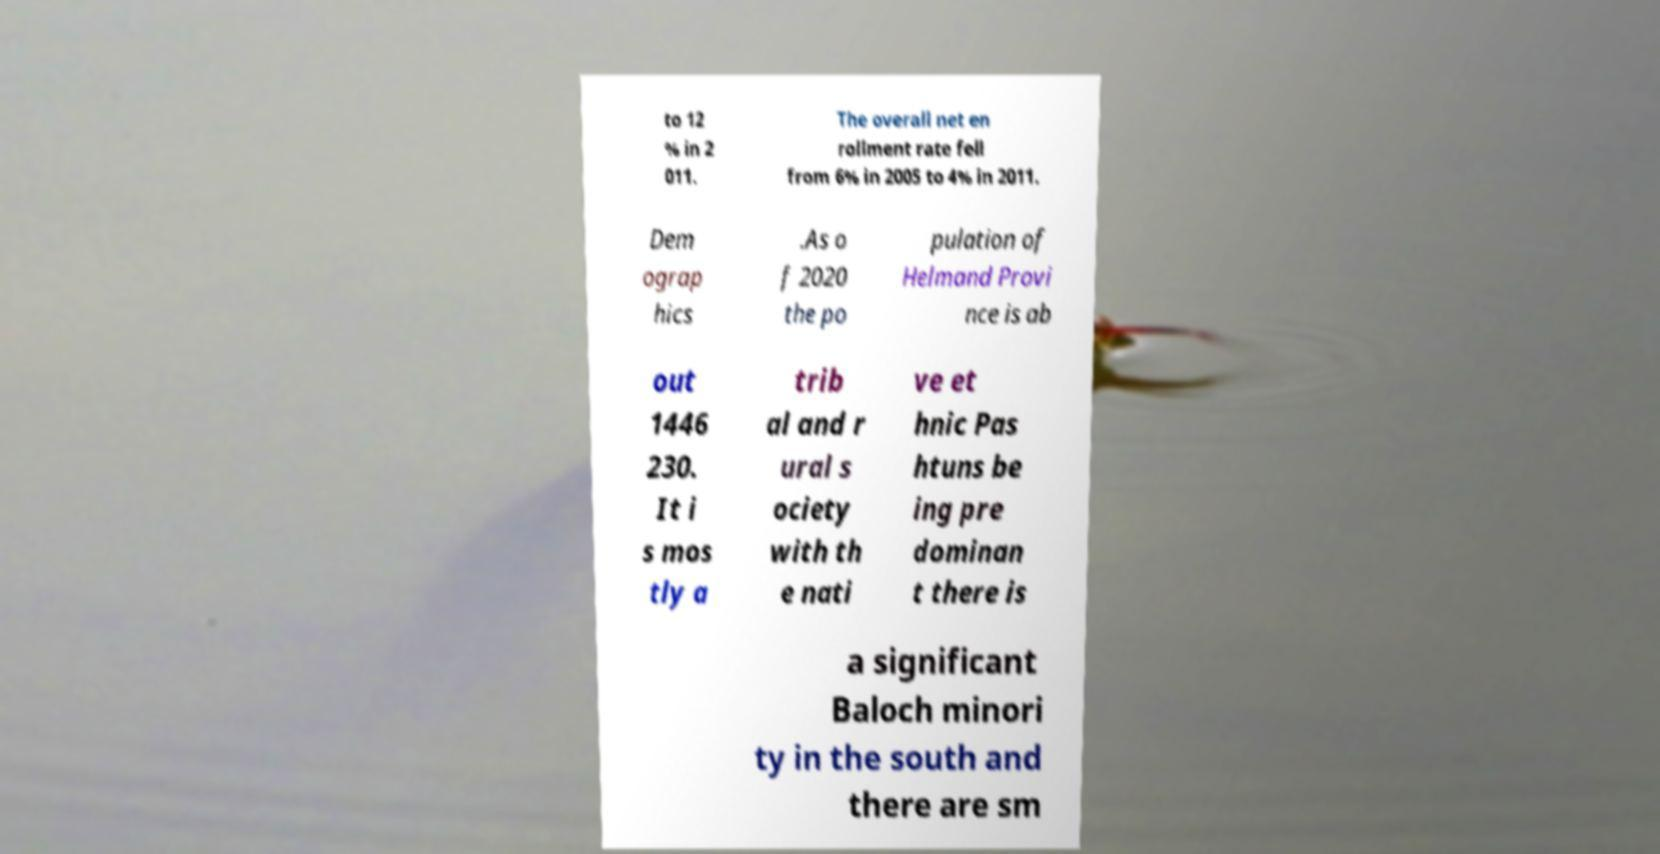There's text embedded in this image that I need extracted. Can you transcribe it verbatim? to 12 % in 2 011. The overall net en rollment rate fell from 6% in 2005 to 4% in 2011. Dem ograp hics .As o f 2020 the po pulation of Helmand Provi nce is ab out 1446 230. It i s mos tly a trib al and r ural s ociety with th e nati ve et hnic Pas htuns be ing pre dominan t there is a significant Baloch minori ty in the south and there are sm 